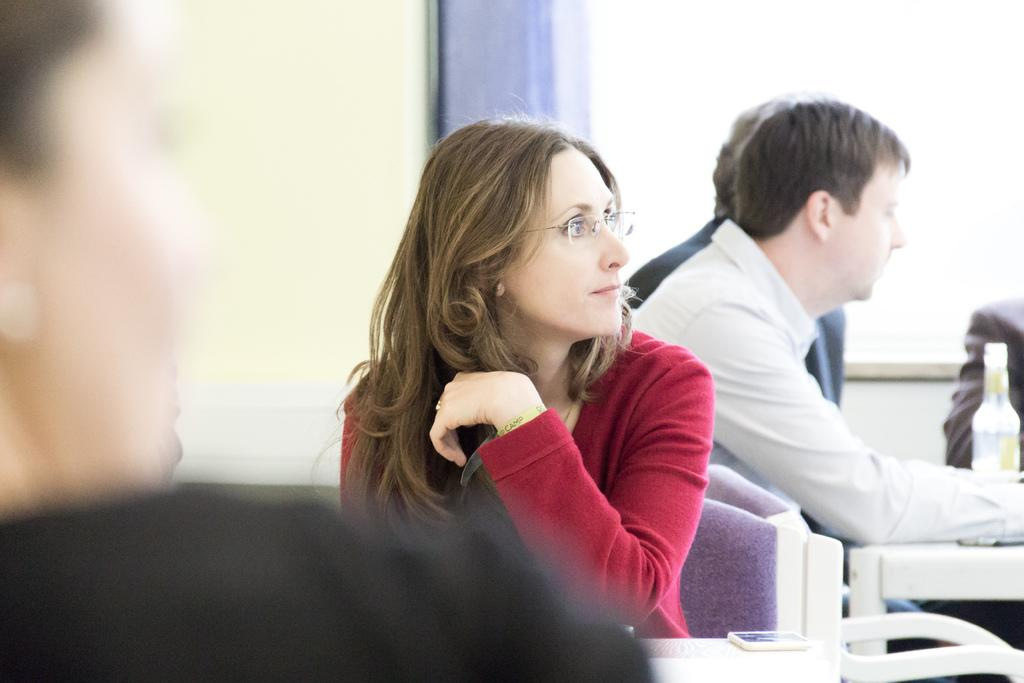How many people are in the image? There is a group of persons in the image. What are the persons doing in the image? The persons are sitting on chairs and having some food item. What can be seen in the background of the image? There is a wall in the background of the image. What belief is being discussed among the group in the image? There is no indication in the image of any specific belief being discussed among the group. 